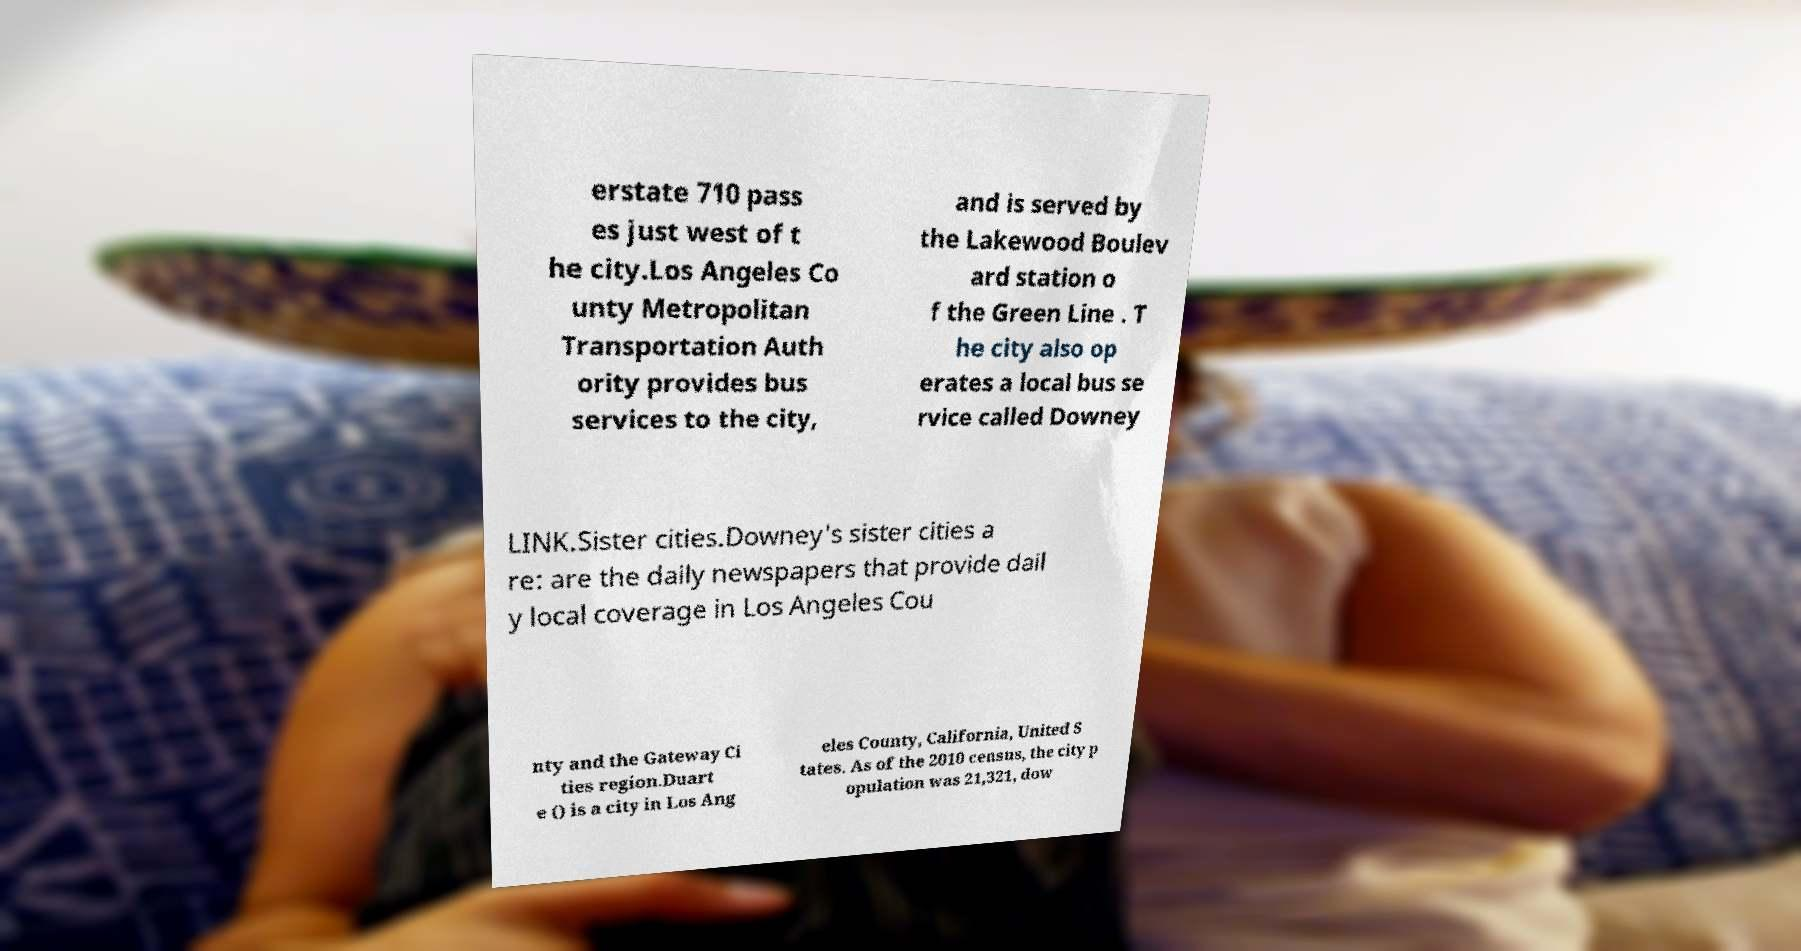What messages or text are displayed in this image? I need them in a readable, typed format. erstate 710 pass es just west of t he city.Los Angeles Co unty Metropolitan Transportation Auth ority provides bus services to the city, and is served by the Lakewood Boulev ard station o f the Green Line . T he city also op erates a local bus se rvice called Downey LINK.Sister cities.Downey's sister cities a re: are the daily newspapers that provide dail y local coverage in Los Angeles Cou nty and the Gateway Ci ties region.Duart e () is a city in Los Ang eles County, California, United S tates. As of the 2010 census, the city p opulation was 21,321, dow 